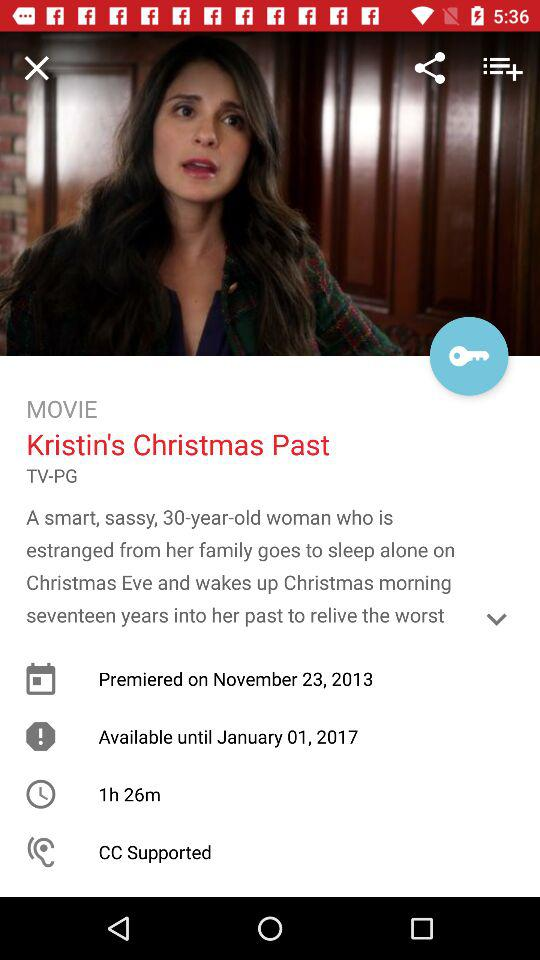On what date did the movie premiere? The movie premiered on November 23, 2013. 